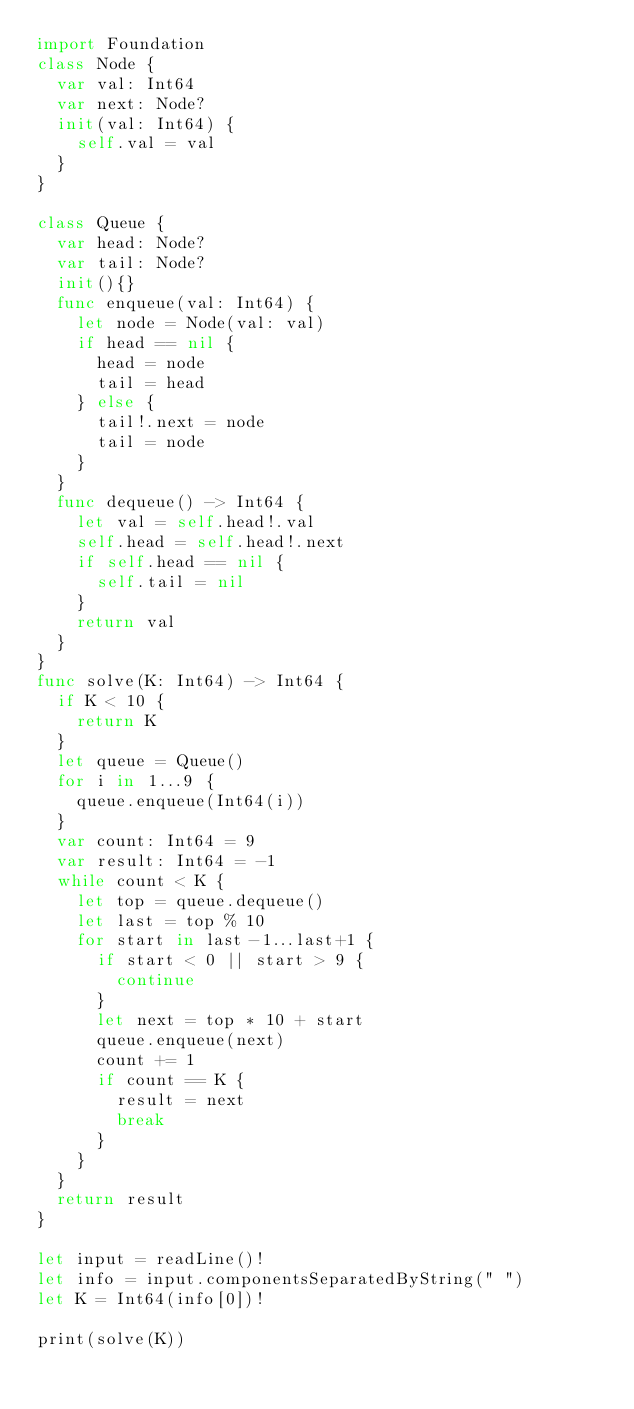<code> <loc_0><loc_0><loc_500><loc_500><_Swift_>import Foundation
class Node {
  var val: Int64
  var next: Node?
  init(val: Int64) {
    self.val = val
  }
}

class Queue {
  var head: Node?
  var tail: Node?
  init(){}
  func enqueue(val: Int64) {
    let node = Node(val: val)
    if head == nil {
      head = node
      tail = head
    } else {
      tail!.next = node
      tail = node
    }
  }
  func dequeue() -> Int64 {
    let val = self.head!.val
    self.head = self.head!.next
    if self.head == nil {
      self.tail = nil
    }
    return val
  }
}
func solve(K: Int64) -> Int64 {
  if K < 10 {
    return K
  }
  let queue = Queue()
  for i in 1...9 {
    queue.enqueue(Int64(i))
  }
  var count: Int64 = 9
  var result: Int64 = -1
  while count < K {
    let top = queue.dequeue()
    let last = top % 10
    for start in last-1...last+1 {
      if start < 0 || start > 9 {
        continue
      }
      let next = top * 10 + start
      queue.enqueue(next)
      count += 1
      if count == K {
        result = next
        break
      }
    }
  }
  return result
}

let input = readLine()!
let info = input.componentsSeparatedByString(" ")
let K = Int64(info[0])!

print(solve(K))
</code> 